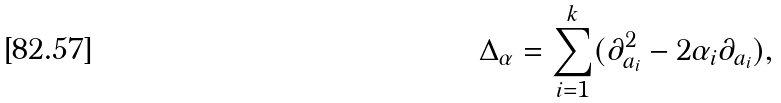<formula> <loc_0><loc_0><loc_500><loc_500>\Delta _ { \alpha } = \sum _ { i = 1 } ^ { k } ( \partial _ { a _ { i } } ^ { 2 } - 2 \alpha _ { i } \partial _ { a _ { i } } ) ,</formula> 